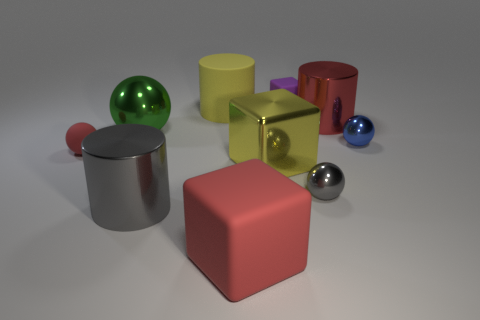Subtract all yellow cylinders. How many cylinders are left? 2 Subtract all gray spheres. How many spheres are left? 3 Subtract all yellow spheres. Subtract all brown cubes. How many spheres are left? 4 Subtract all cylinders. How many objects are left? 7 Add 8 big yellow cylinders. How many big yellow cylinders are left? 9 Add 7 red cubes. How many red cubes exist? 8 Subtract 1 green spheres. How many objects are left? 9 Subtract all small blue metal balls. Subtract all yellow matte cylinders. How many objects are left? 8 